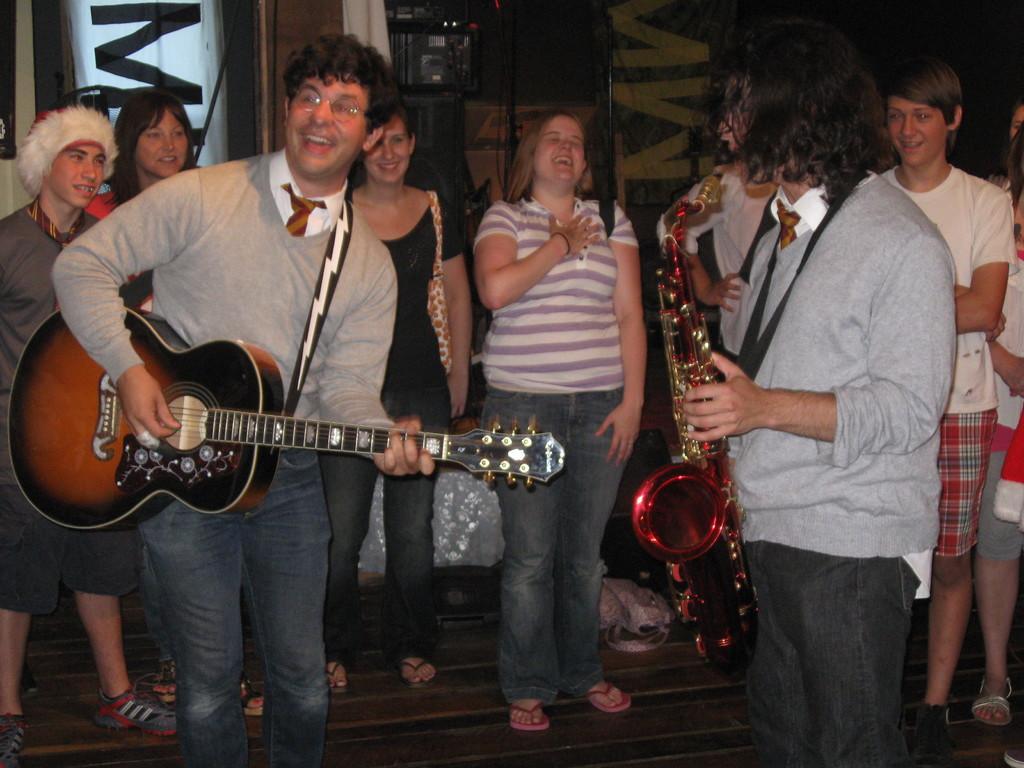In one or two sentences, can you explain what this image depicts? In a picture there are many people are standing in which two people are playing musical instruments other people was standing and laughing woman is carrying a handbag there are sound system near to the people. 